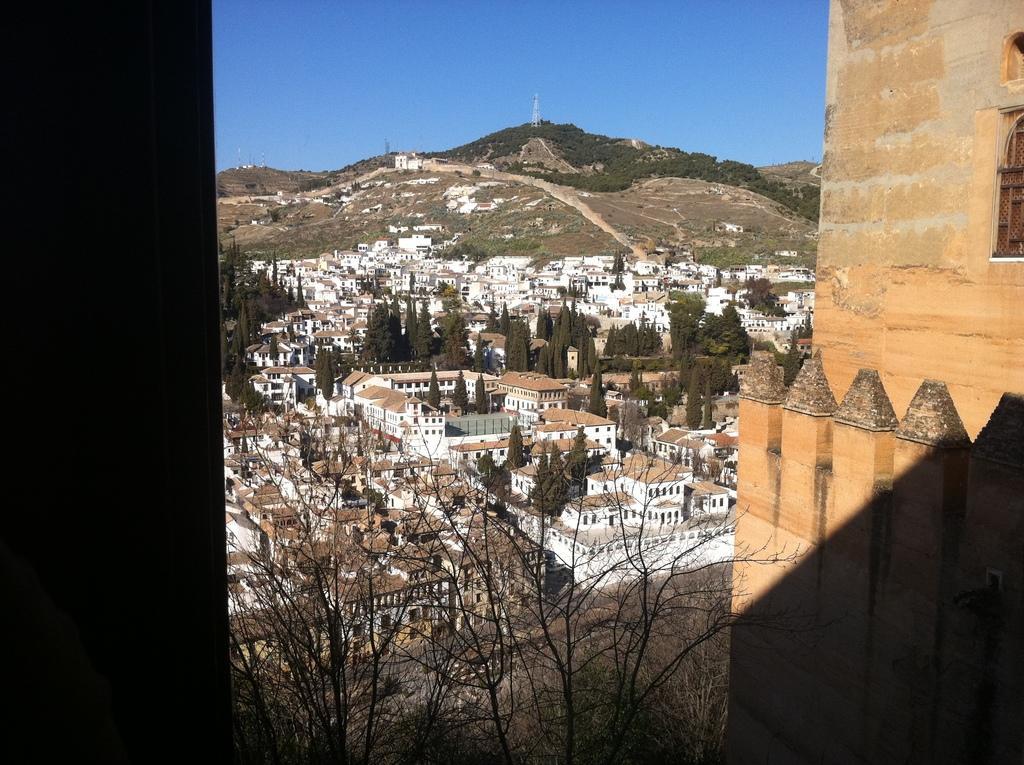Please provide a concise description of this image. This image is taken from the top view where we can see there are so many buildings at the bottom. In between the buildings there are trees. In the background there is a hill on which there is a tower. On the right side there is a building. At the top there is the sky. 